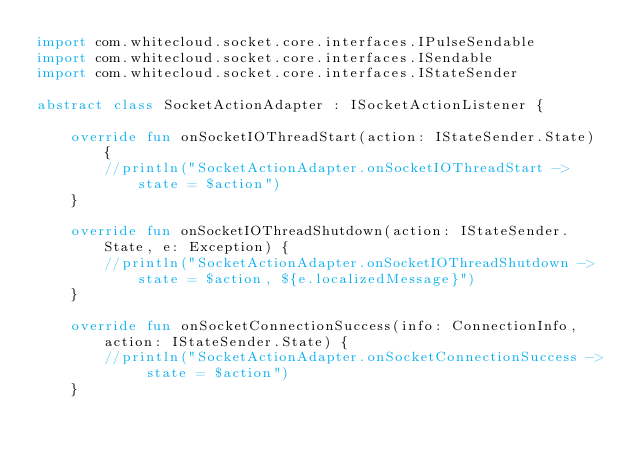Convert code to text. <code><loc_0><loc_0><loc_500><loc_500><_Kotlin_>import com.whitecloud.socket.core.interfaces.IPulseSendable
import com.whitecloud.socket.core.interfaces.ISendable
import com.whitecloud.socket.core.interfaces.IStateSender

abstract class SocketActionAdapter : ISocketActionListener {

    override fun onSocketIOThreadStart(action: IStateSender.State) {
        //println("SocketActionAdapter.onSocketIOThreadStart -> state = $action")
    }

    override fun onSocketIOThreadShutdown(action: IStateSender.State, e: Exception) {
        //println("SocketActionAdapter.onSocketIOThreadShutdown -> state = $action, ${e.localizedMessage}")
    }

    override fun onSocketConnectionSuccess(info: ConnectionInfo, action: IStateSender.State) {
        //println("SocketActionAdapter.onSocketConnectionSuccess -> state = $action")
    }
</code> 